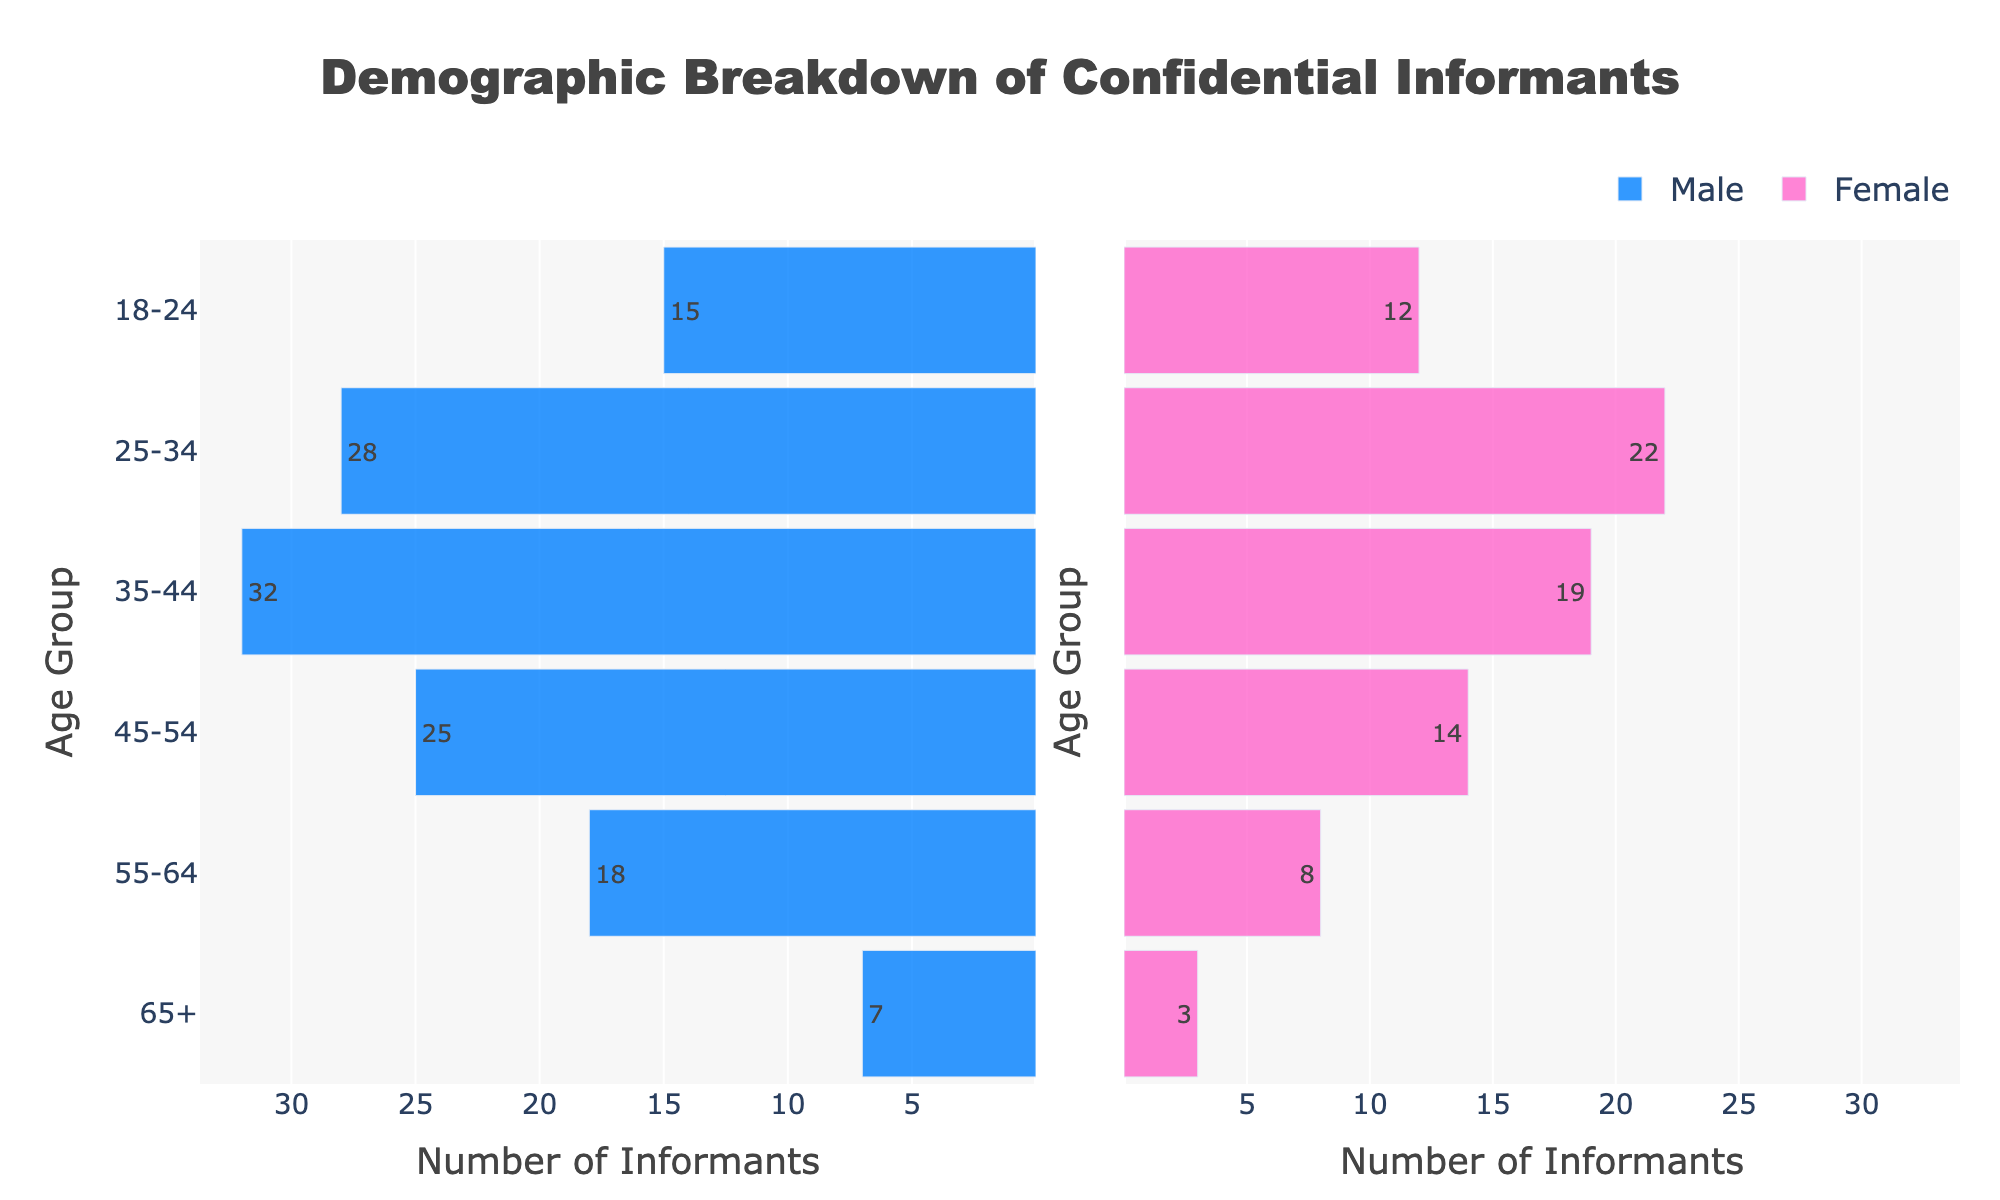What is the title of the figure? The title can be found at the top of the figure. It summarizes the content.
Answer: Demographic Breakdown of Confidential Informants How many age groups are represented in the figure? By looking at the y-axis, we can count the number of distinct age groups.
Answer: 6 Which gender has more informants in the age group 18-24? By looking at the bars corresponding to the age group 18-24, we can compare the length of the male and female bars.
Answer: Male What is the total number of female informants in all age groups combined? Sum the numbers of female informants in each age group: 12 + 22 + 19 + 14 + 8 + 3.
Answer: 78 In which age group do male informants exceed female informants by the largest margin? Calculate the difference between male and female informants in each age group, then find the group with the highest difference.
Answer: 35-44 What is the total number of informants in the age group 55-64? Add the number of male and female informants in the age group 55-64: 18 (Male) + 8 (Female).
Answer: 26 Which age group has the fewest female informants? Look for the age group with the shortest bar in the female section.
Answer: 65+ Do male or female informants have a higher maximum number in any single age group, and which group is it? Compare the highest number of informants in a single age group for males and females.
Answer: Male, 35-44 What is the difference in the number of male and female informants in the 45-54 age group? Subtract the number of female informants from male informants in age group 45-54: 25 - 14.
Answer: 11 